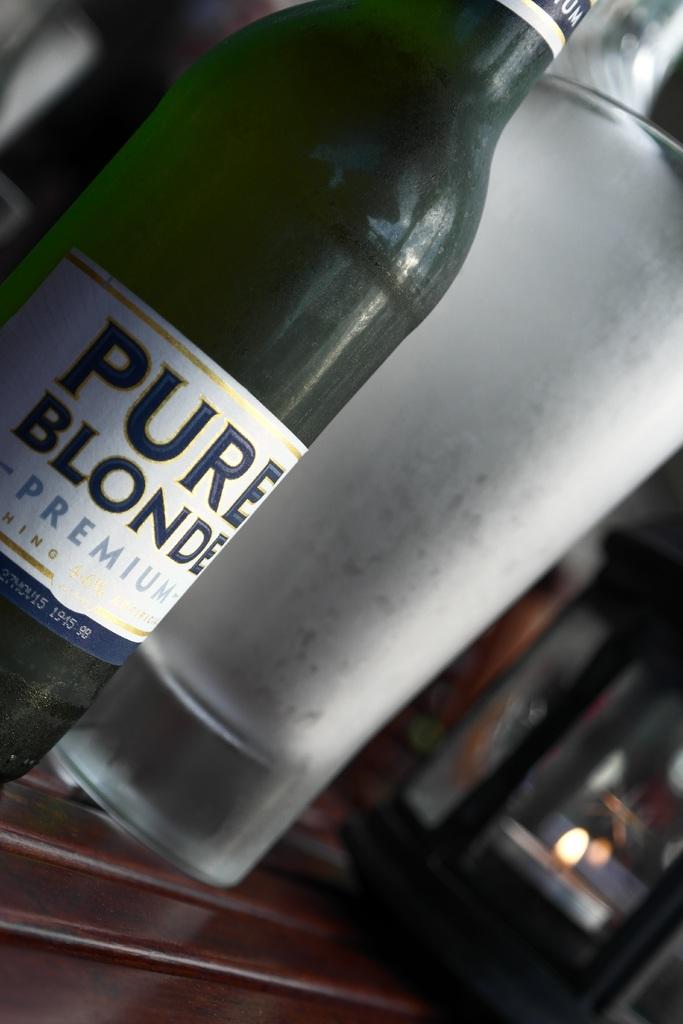What type of beer is shown?
Ensure brevity in your answer.  Pure blonde. Pure blonder?
Give a very brief answer. Yes. 